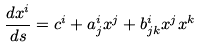<formula> <loc_0><loc_0><loc_500><loc_500>\frac { d x ^ { i } } { d s } = c ^ { i } + a ^ { i } _ { j } x ^ { j } + b ^ { i } _ { j k } x ^ { j } x ^ { k }</formula> 